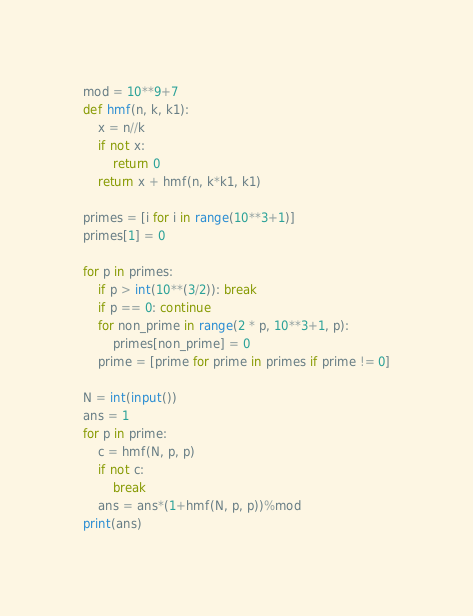<code> <loc_0><loc_0><loc_500><loc_500><_Python_>mod = 10**9+7
def hmf(n, k, k1):
    x = n//k
    if not x:
        return 0
    return x + hmf(n, k*k1, k1)

primes = [i for i in range(10**3+1)]
primes[1] = 0 

for p in primes:
    if p > int(10**(3/2)): break
    if p == 0: continue
    for non_prime in range(2 * p, 10**3+1, p): 
        primes[non_prime] = 0
    prime = [prime for prime in primes if prime != 0]

N = int(input())
ans = 1
for p in prime:
    c = hmf(N, p, p)
    if not c:
        break
    ans = ans*(1+hmf(N, p, p))%mod
print(ans)</code> 